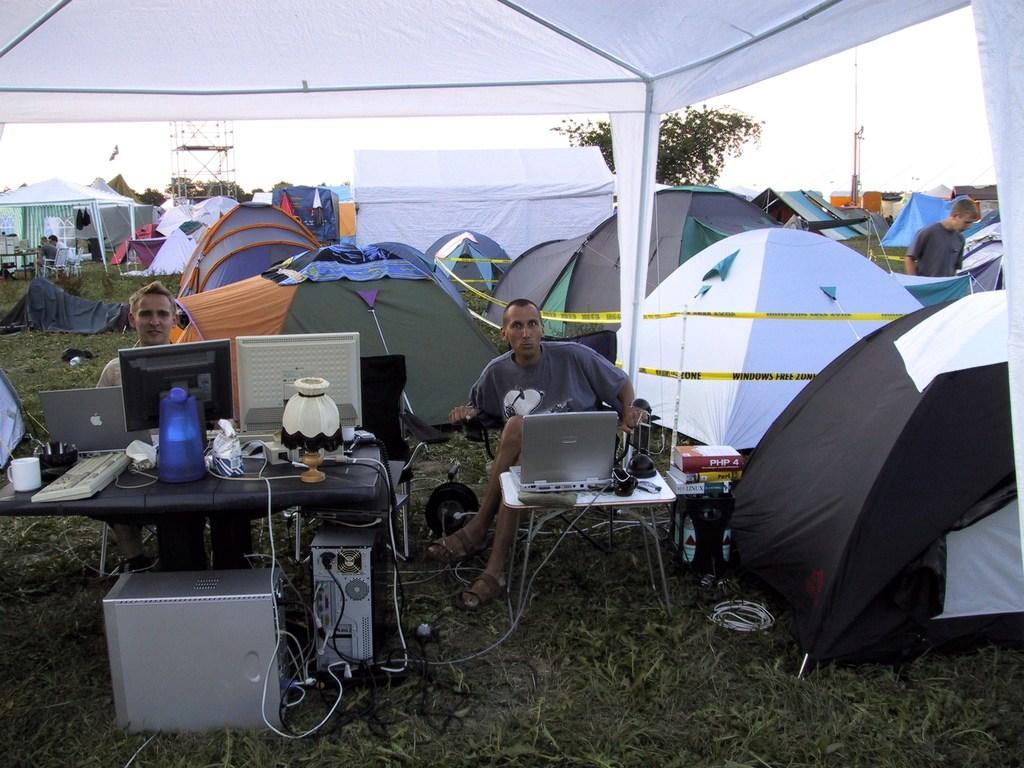Can you describe this image briefly? This looks like camping. There is a table, on that there are computers, laptops. There are books in the middle. There are two persons sitting on chairs in the middle. There are trees in the middle. There is sky at the top. 